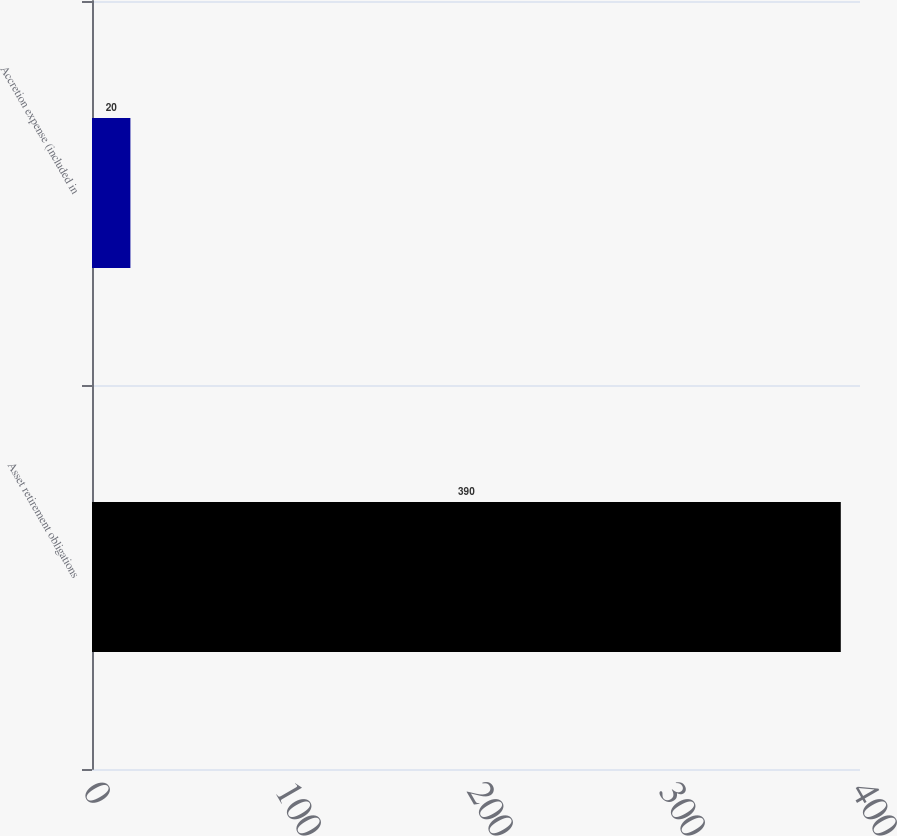<chart> <loc_0><loc_0><loc_500><loc_500><bar_chart><fcel>Asset retirement obligations<fcel>Accretion expense (included in<nl><fcel>390<fcel>20<nl></chart> 